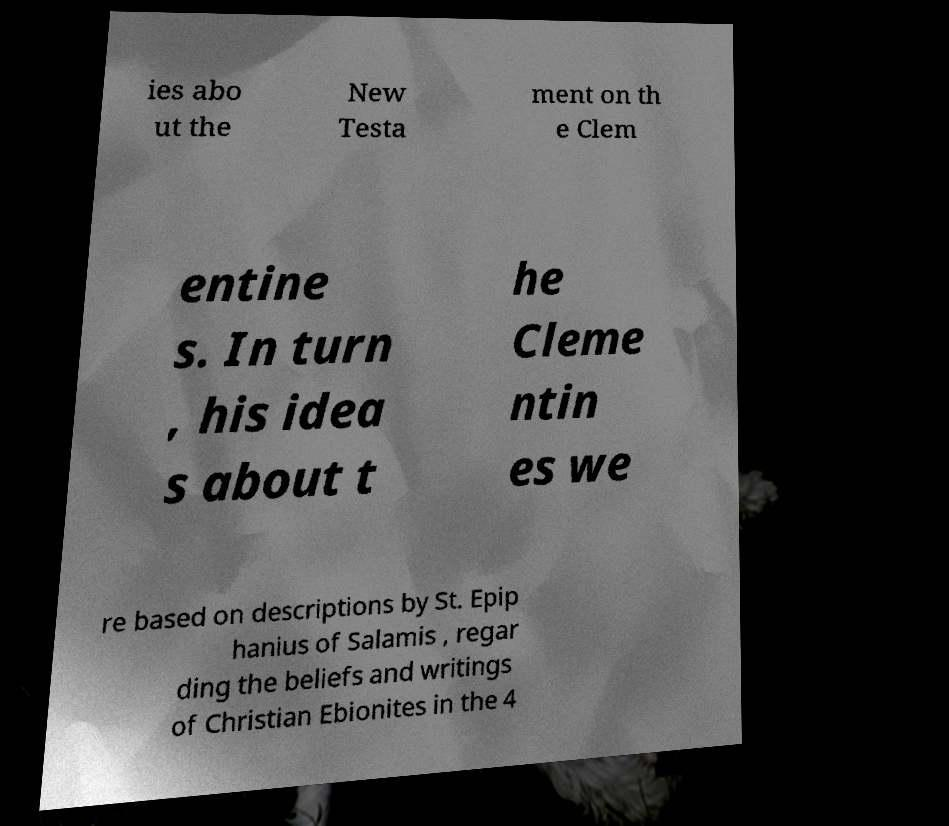What messages or text are displayed in this image? I need them in a readable, typed format. ies abo ut the New Testa ment on th e Clem entine s. In turn , his idea s about t he Cleme ntin es we re based on descriptions by St. Epip hanius of Salamis , regar ding the beliefs and writings of Christian Ebionites in the 4 